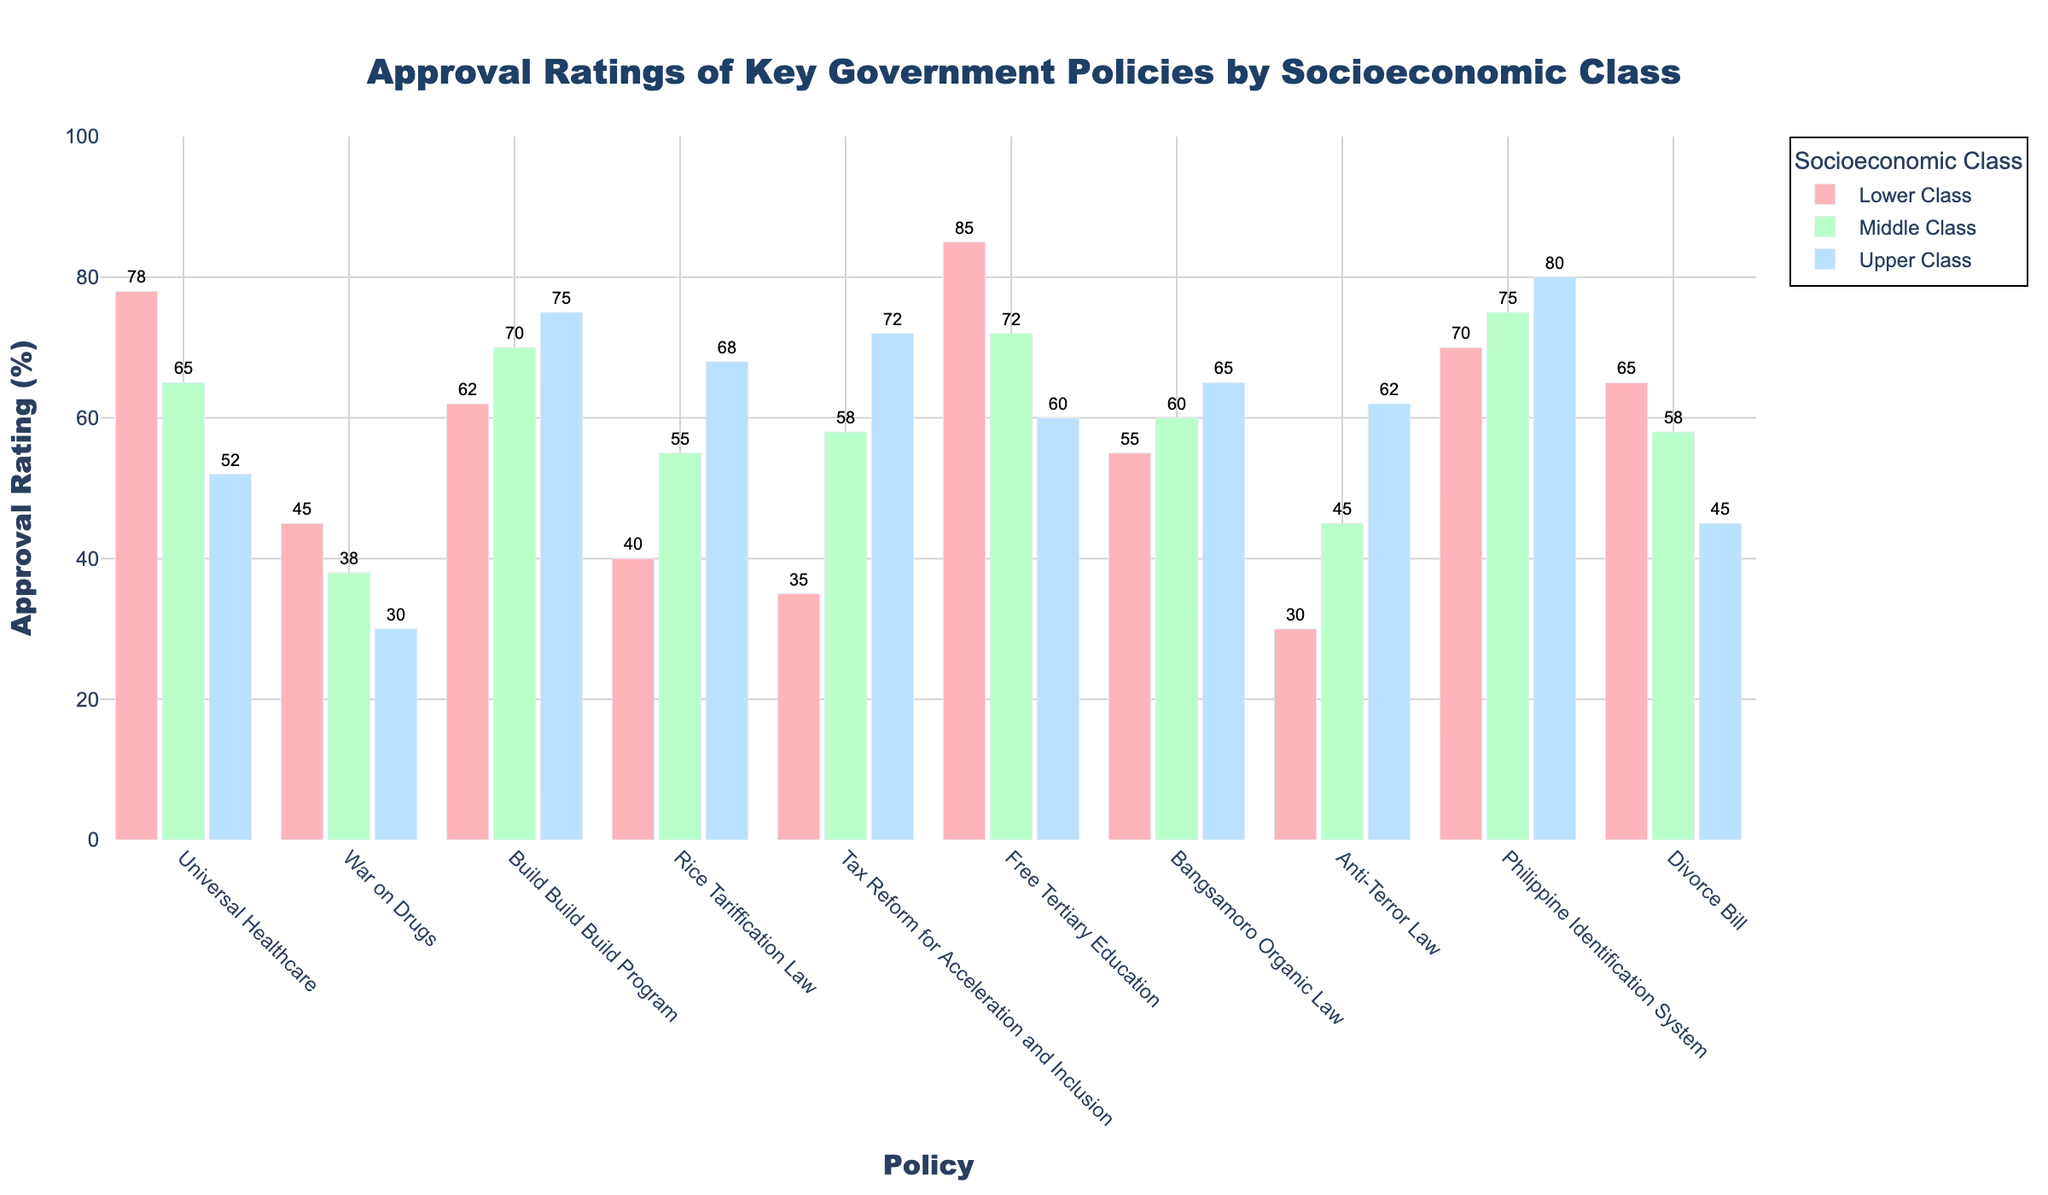What's the highest approval rating for Universal Healthcare among the socioeconomic classes? Check the heights of the bars corresponding to Universal Healthcare. The Lower Class has the highest bar at 78%.
Answer: 78% Which policy has the highest approval rating in the Upper Class? Look at the tallest bar solely within the Upper Class category. The tallest bar is for the Philippine Identification System at 80%.
Answer: Philippine Identification System How does the approval rating of Free Tertiary Education compare between the Lower and Upper Classes? Compare the heights of the bars for Free Tertiary Education. The Lower Class has an approval rating of 85%, while the Upper Class has a lower approval rating of 60%.
Answer: Lower Class approval rating is higher by 25% Which socio-economic class has the lowest approval rating for the Anti-Terror Law? Look at the shortest bar for Anti-Terror Law. The shortest bar is in the Lower Class with an approval rating of 30%.
Answer: Lower Class For the Divorce Bill, how much higher is the approval rating for the Lower Class compared to the Upper Class? Subtract the approval rating of the Upper Class from the Lower Class for Divorce Bill; 65% - 45% = 20%.
Answer: 20% What's the average approval rating for the War on Drugs across all classes? Sum the approval ratings for all classes and divide by 3; (45 + 38 + 30) / 3 = 37.67%.
Answer: 37.67% Which policy has the smallest difference in approval ratings between Lower and Middle Classes? Calculate the differences between Lower and Middle Classes for all policies, find the smallest difference; the Anti-Terror Law has the smallest difference of 15% (45% - 30%).
Answer: Anti-Terror Law What is the total approval rating for the Build Build Build Program when averaged across all classes? Sum the approval ratings for all classes and divide by 3; (62 + 70 + 75) / 3 = 69%.
Answer: 69% Which class has the most consistent approval ratings across all policies? Observe which class has bars with relatively similar heights across all policies. The Middle Class seems to have the most consistent approval ratings, generally within the middle range.
Answer: Middle Class 